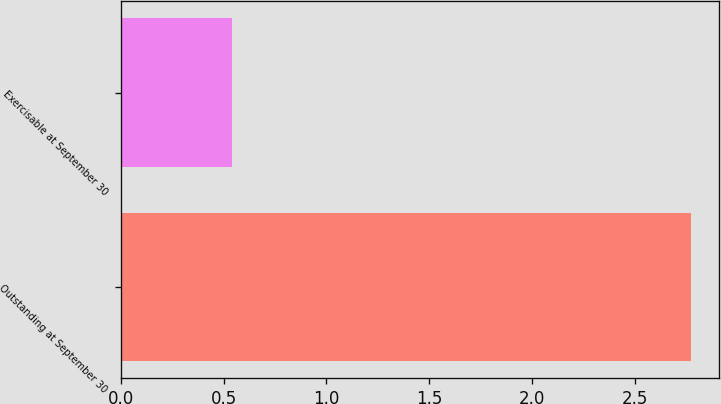Convert chart to OTSL. <chart><loc_0><loc_0><loc_500><loc_500><bar_chart><fcel>Outstanding at September 30<fcel>Exercisable at September 30<nl><fcel>2.77<fcel>0.54<nl></chart> 